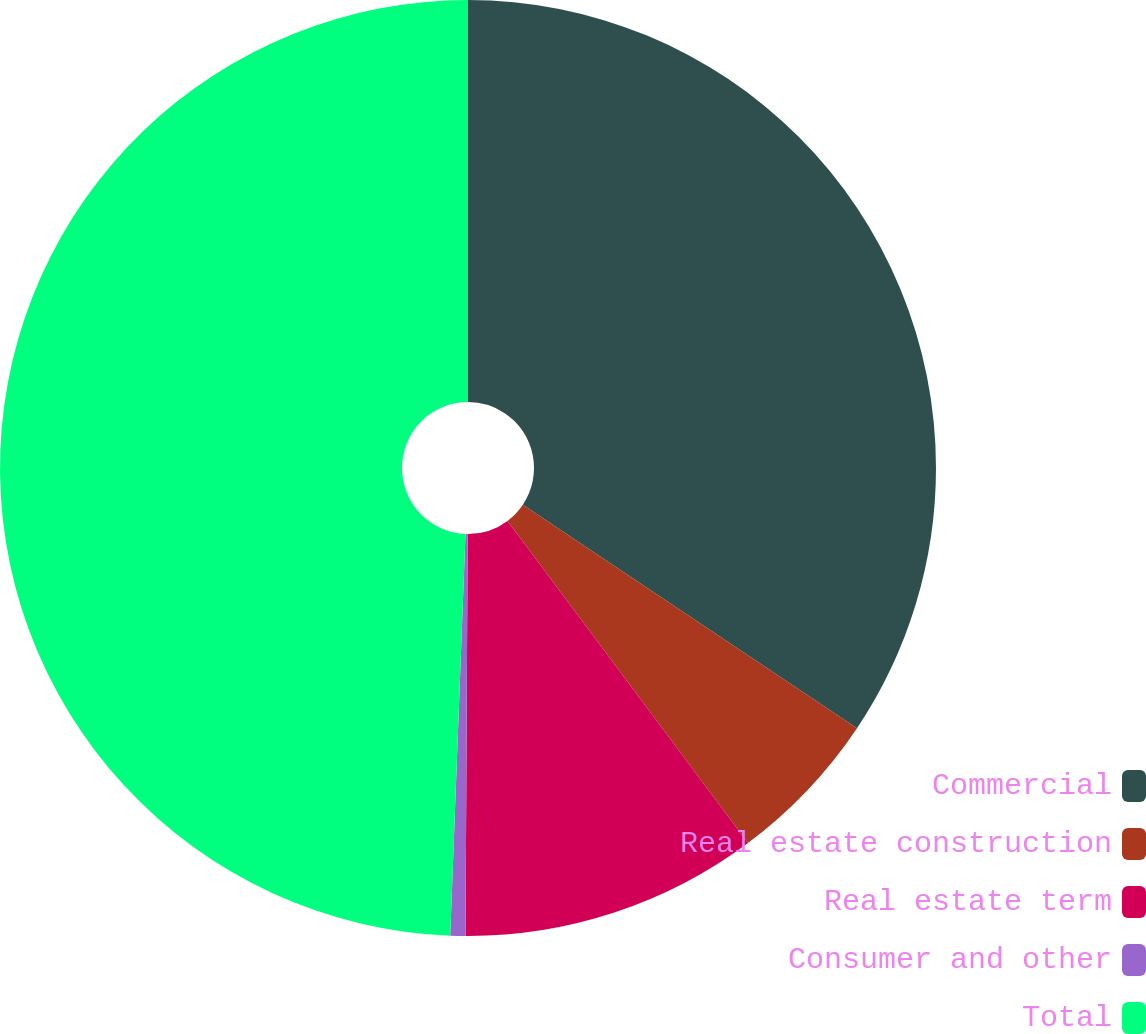<chart> <loc_0><loc_0><loc_500><loc_500><pie_chart><fcel>Commercial<fcel>Real estate construction<fcel>Real estate term<fcel>Consumer and other<fcel>Total<nl><fcel>34.38%<fcel>5.41%<fcel>10.29%<fcel>0.52%<fcel>49.39%<nl></chart> 